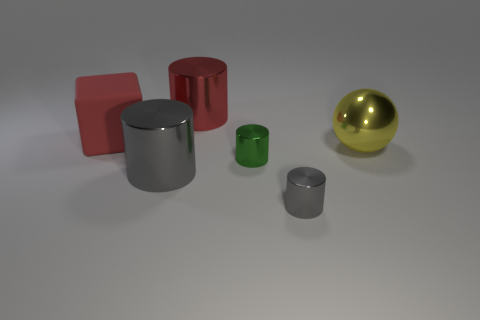Is the color of the large cylinder that is left of the big red shiny thing the same as the big matte block? The large cylinder to the left of the big red shiny object is silver, which differs from the color of the large matte block, which is red. Thus, their colors are not the same. 